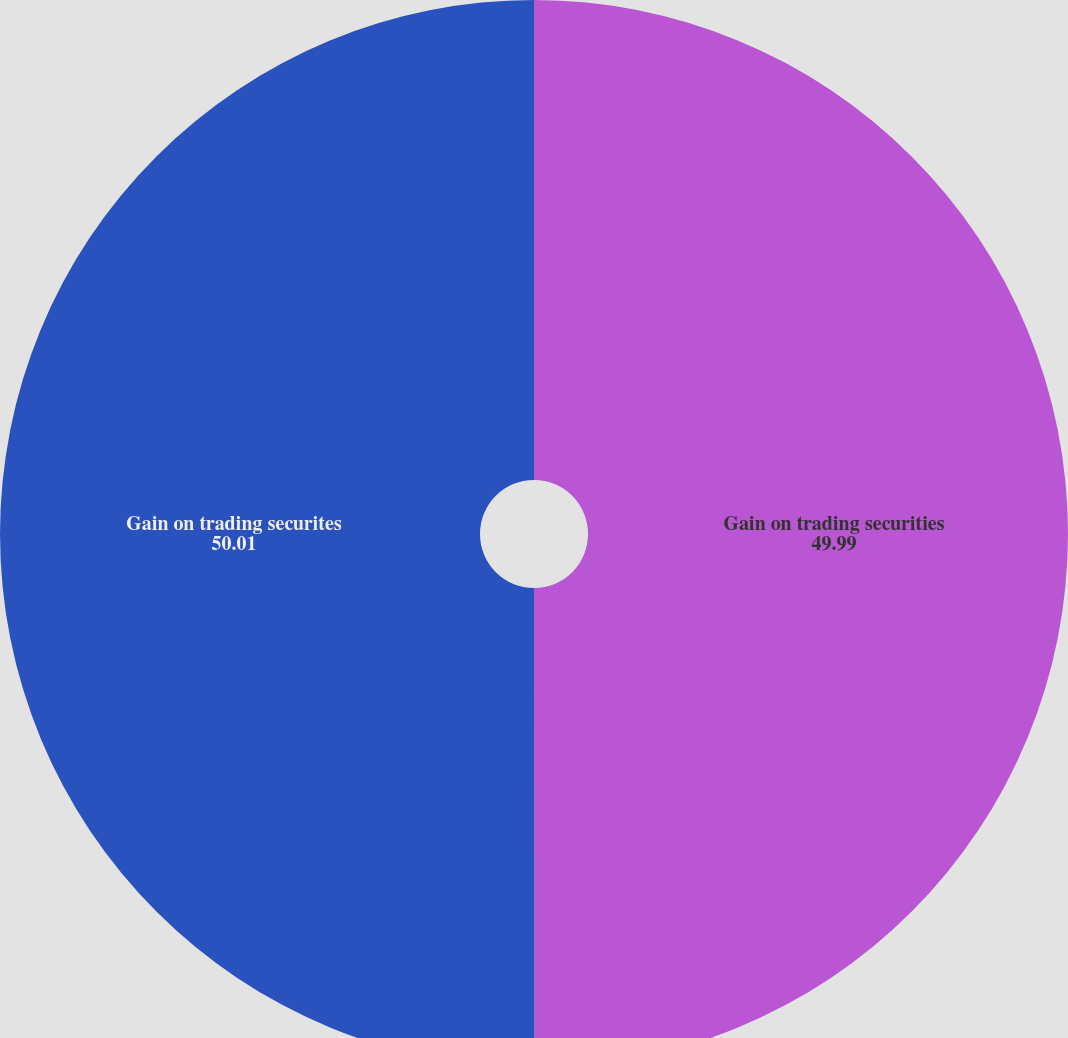Convert chart to OTSL. <chart><loc_0><loc_0><loc_500><loc_500><pie_chart><fcel>Gain on trading securities<fcel>Gain on trading securites<nl><fcel>49.99%<fcel>50.01%<nl></chart> 